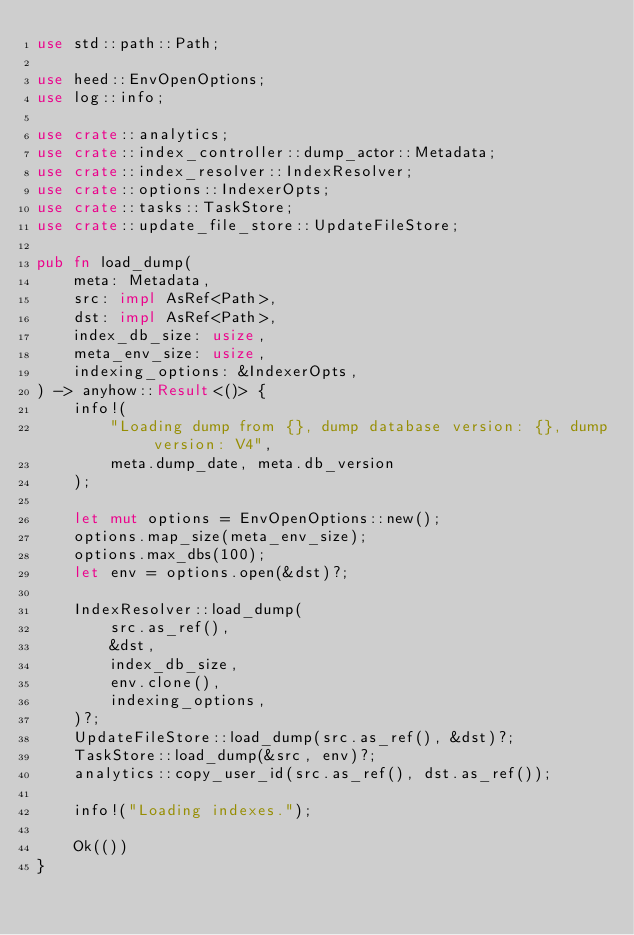Convert code to text. <code><loc_0><loc_0><loc_500><loc_500><_Rust_>use std::path::Path;

use heed::EnvOpenOptions;
use log::info;

use crate::analytics;
use crate::index_controller::dump_actor::Metadata;
use crate::index_resolver::IndexResolver;
use crate::options::IndexerOpts;
use crate::tasks::TaskStore;
use crate::update_file_store::UpdateFileStore;

pub fn load_dump(
    meta: Metadata,
    src: impl AsRef<Path>,
    dst: impl AsRef<Path>,
    index_db_size: usize,
    meta_env_size: usize,
    indexing_options: &IndexerOpts,
) -> anyhow::Result<()> {
    info!(
        "Loading dump from {}, dump database version: {}, dump version: V4",
        meta.dump_date, meta.db_version
    );

    let mut options = EnvOpenOptions::new();
    options.map_size(meta_env_size);
    options.max_dbs(100);
    let env = options.open(&dst)?;

    IndexResolver::load_dump(
        src.as_ref(),
        &dst,
        index_db_size,
        env.clone(),
        indexing_options,
    )?;
    UpdateFileStore::load_dump(src.as_ref(), &dst)?;
    TaskStore::load_dump(&src, env)?;
    analytics::copy_user_id(src.as_ref(), dst.as_ref());

    info!("Loading indexes.");

    Ok(())
}
</code> 